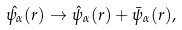Convert formula to latex. <formula><loc_0><loc_0><loc_500><loc_500>\hat { \psi _ { \alpha } } ( r ) \rightarrow \hat { \psi } _ { \alpha } ( r ) + \bar { \psi } _ { \alpha } ( r ) ,</formula> 